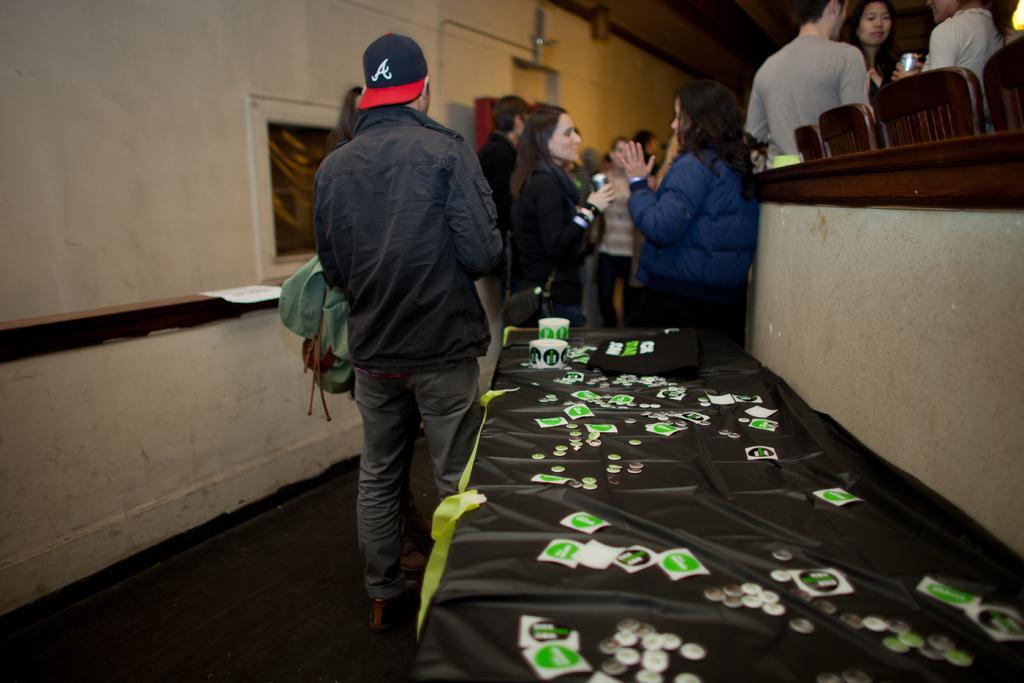In one or two sentences, can you explain what this image depicts? In this image, we can see people, wooden objects, walls and few objects. In the middle of the image, we can see a banner. On top of that we can see coins, cards and few things. In the bottom left side of the image, we can see the floor. 